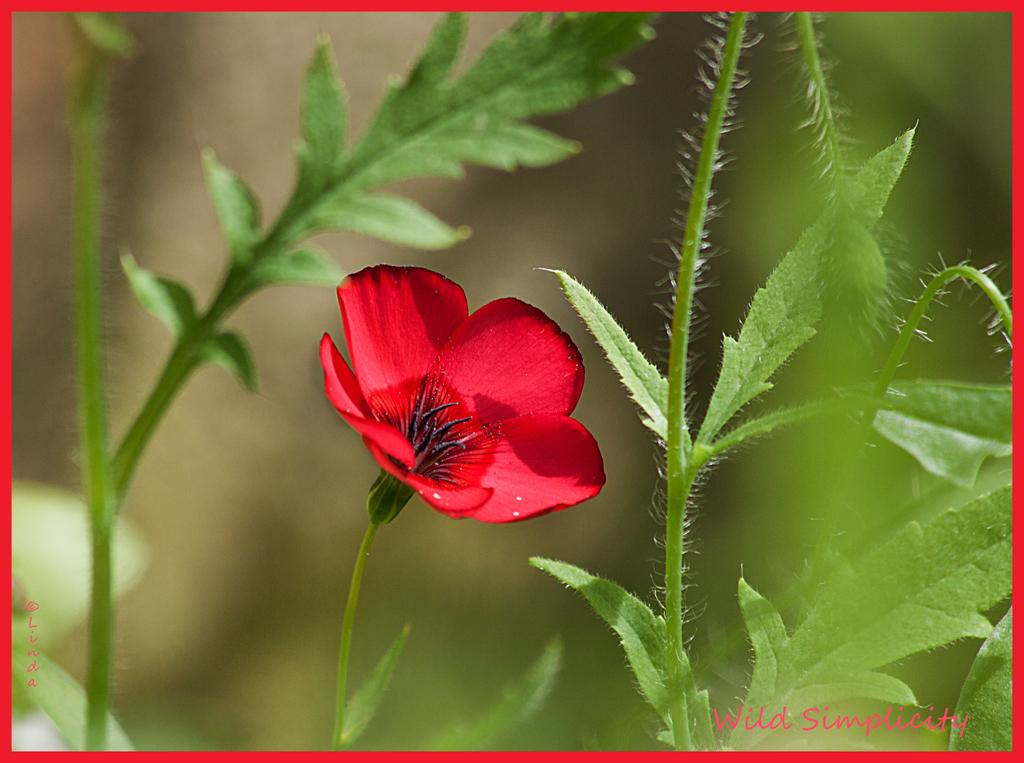What is the main subject of the image? There is a flower in the image. What else can be seen in the image besides the flower? There are leaves in the image. Can you describe the background of the image? The background of the image is blurry. How does the fan contribute to the image? There is no fan present in the image. What type of feeling does the quiver evoke in the image? There is no quiver present in the image. 